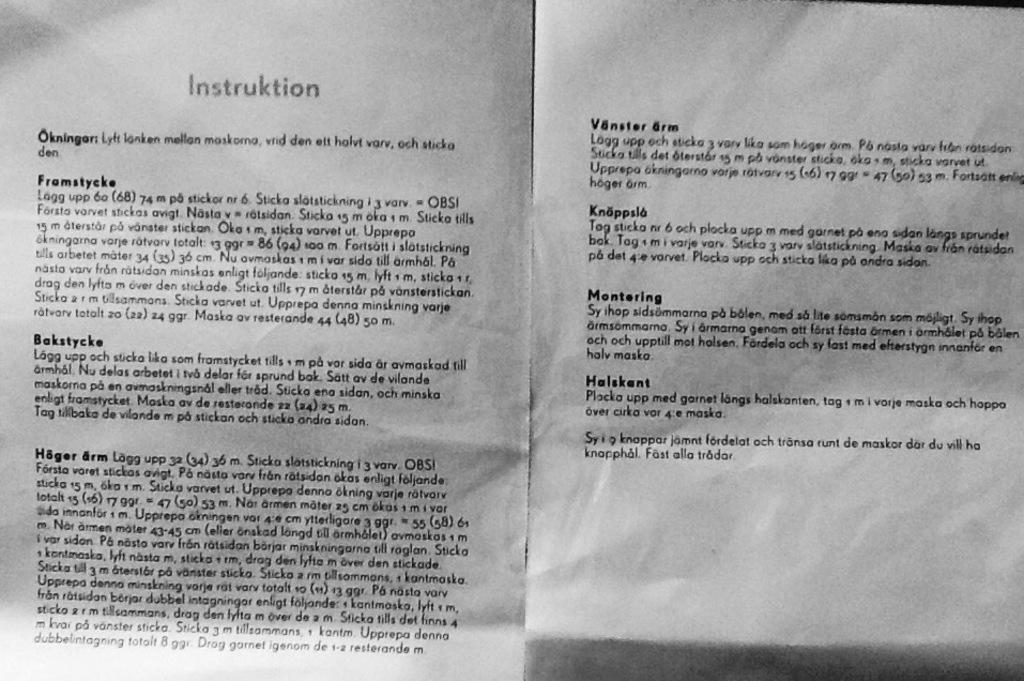<image>
Relay a brief, clear account of the picture shown. A scan two pages of some kind of foreign instructions. 